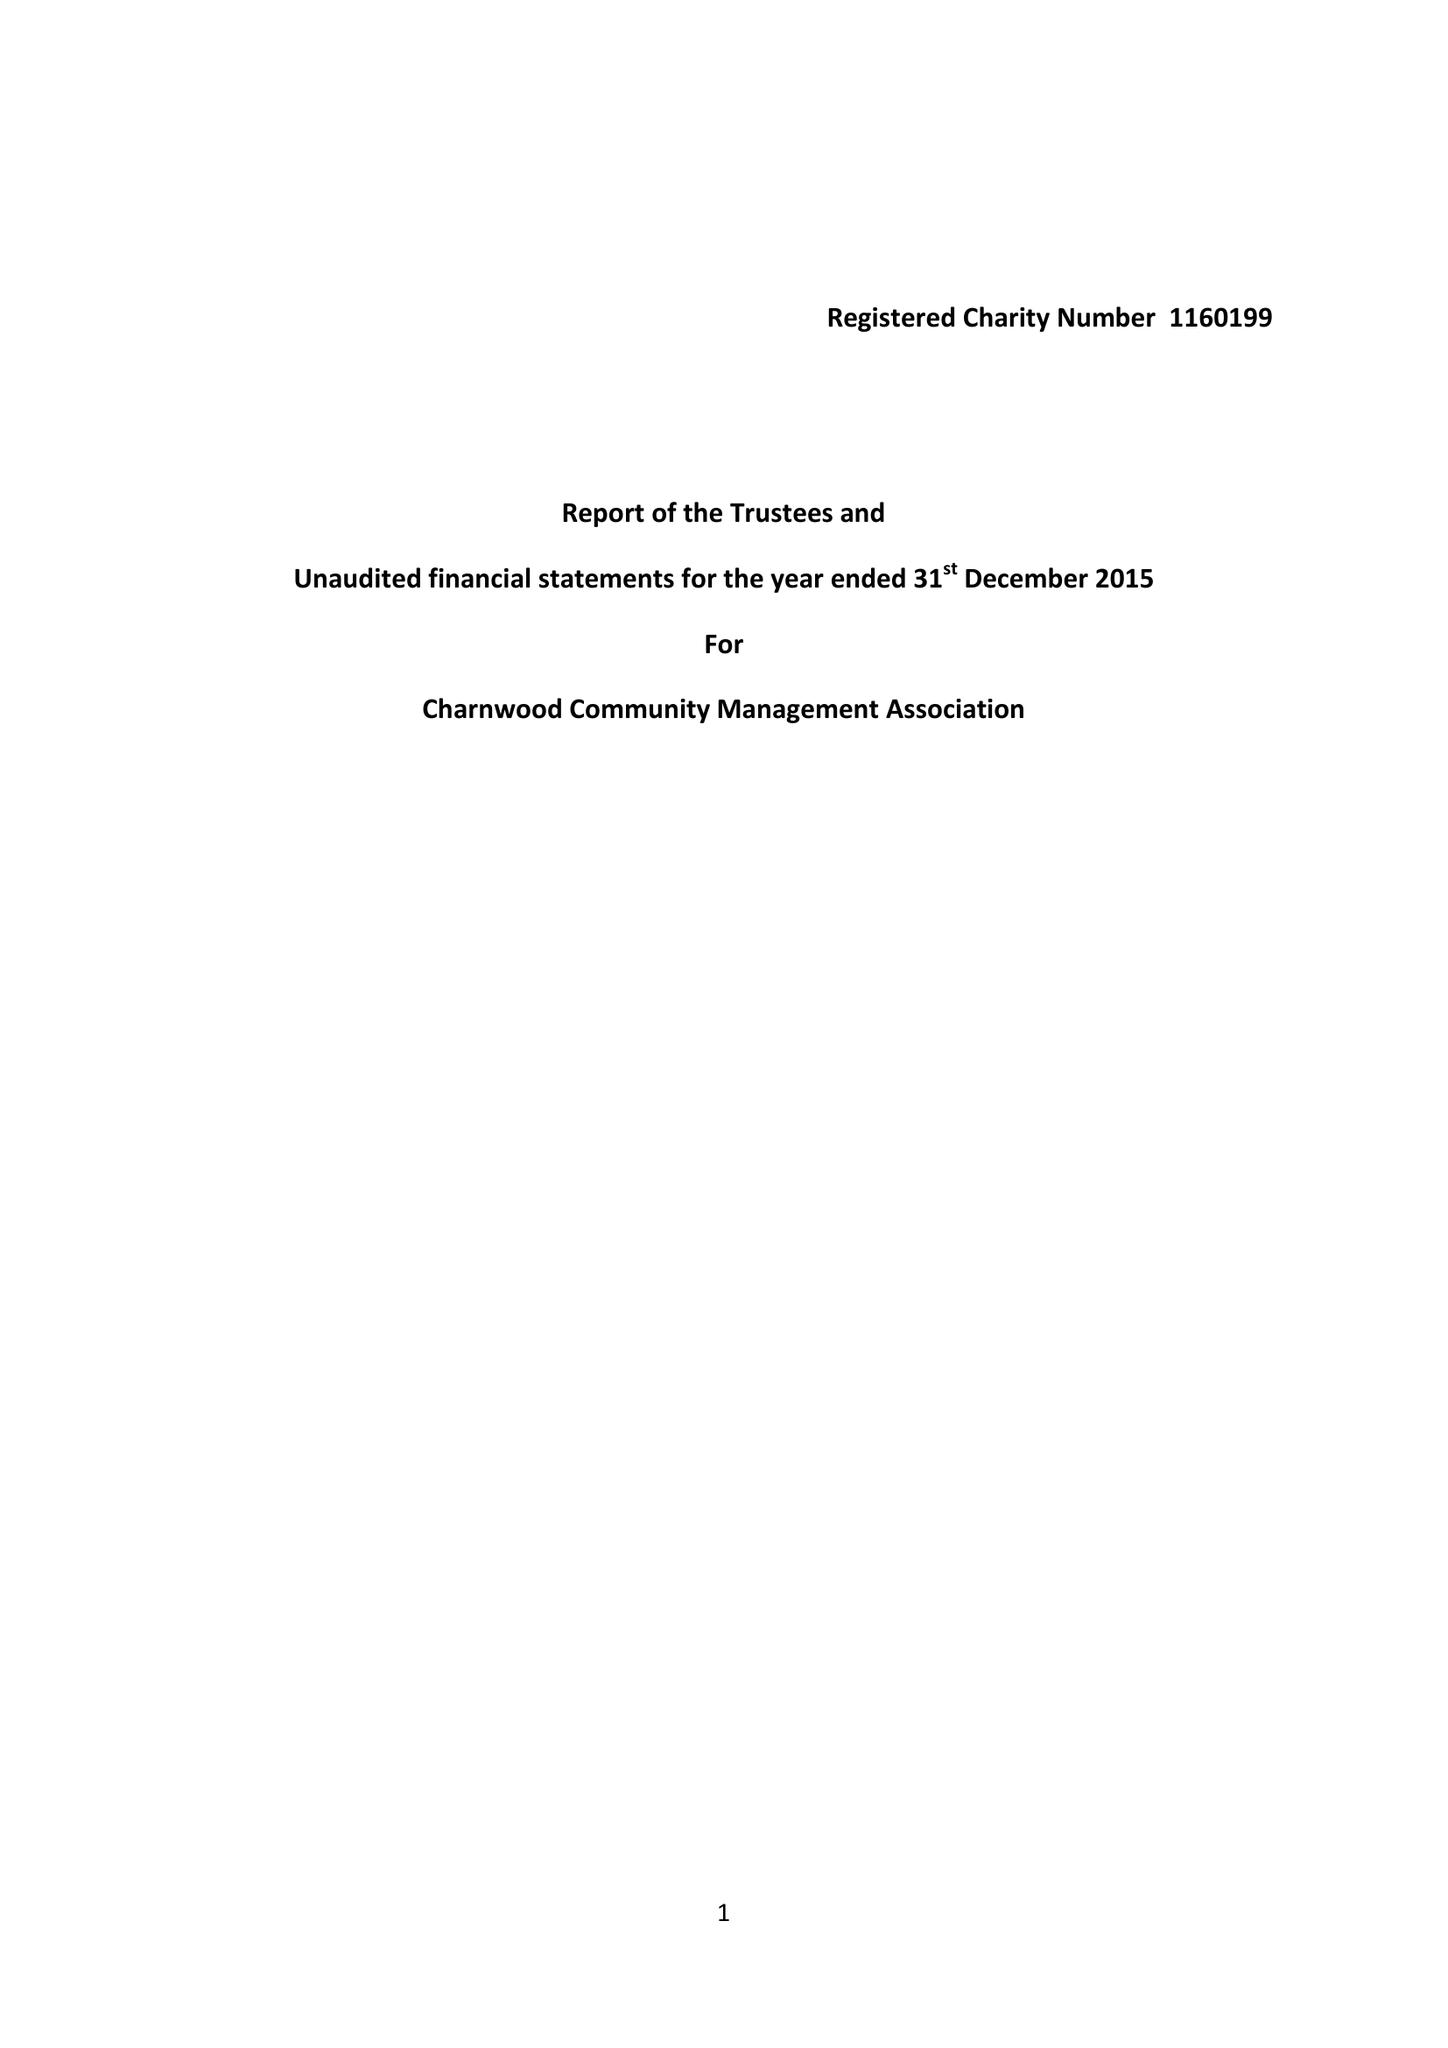What is the value for the report_date?
Answer the question using a single word or phrase. 2015-12-31 